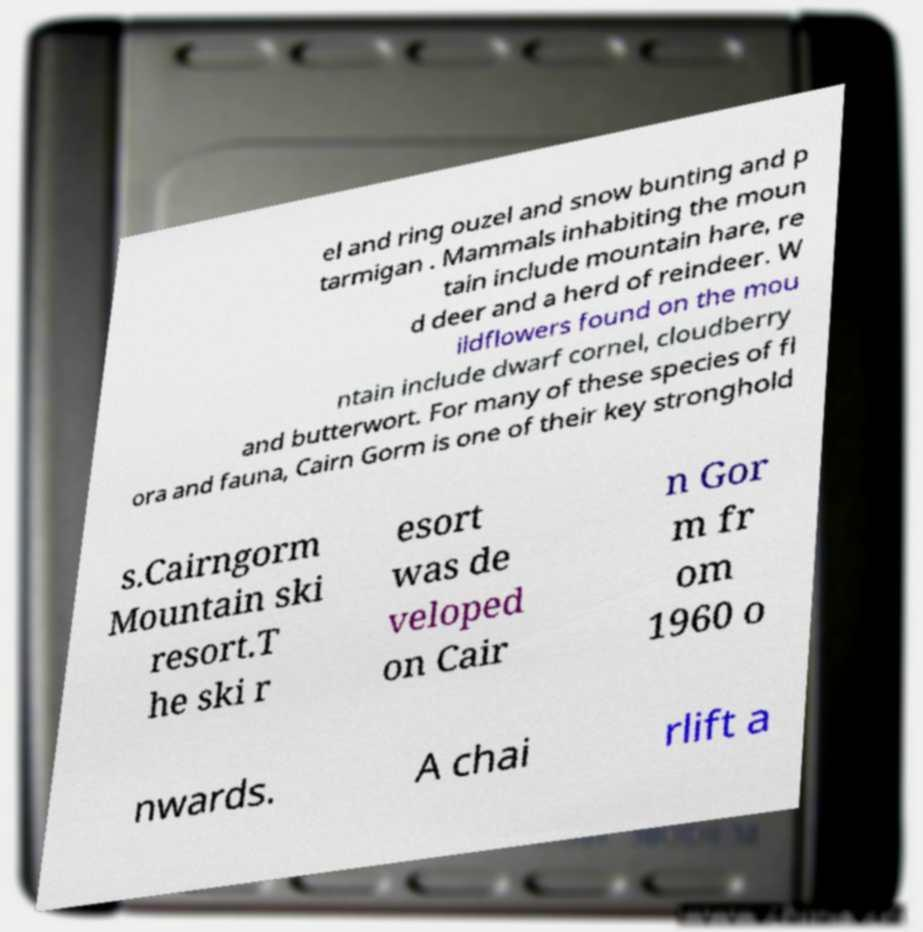I need the written content from this picture converted into text. Can you do that? el and ring ouzel and snow bunting and p tarmigan . Mammals inhabiting the moun tain include mountain hare, re d deer and a herd of reindeer. W ildflowers found on the mou ntain include dwarf cornel, cloudberry and butterwort. For many of these species of fl ora and fauna, Cairn Gorm is one of their key stronghold s.Cairngorm Mountain ski resort.T he ski r esort was de veloped on Cair n Gor m fr om 1960 o nwards. A chai rlift a 